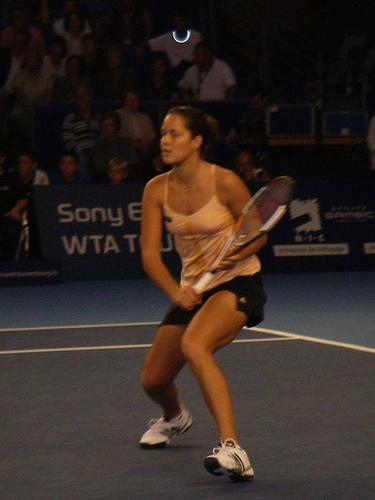What is the woman prepared to do? hit ball 